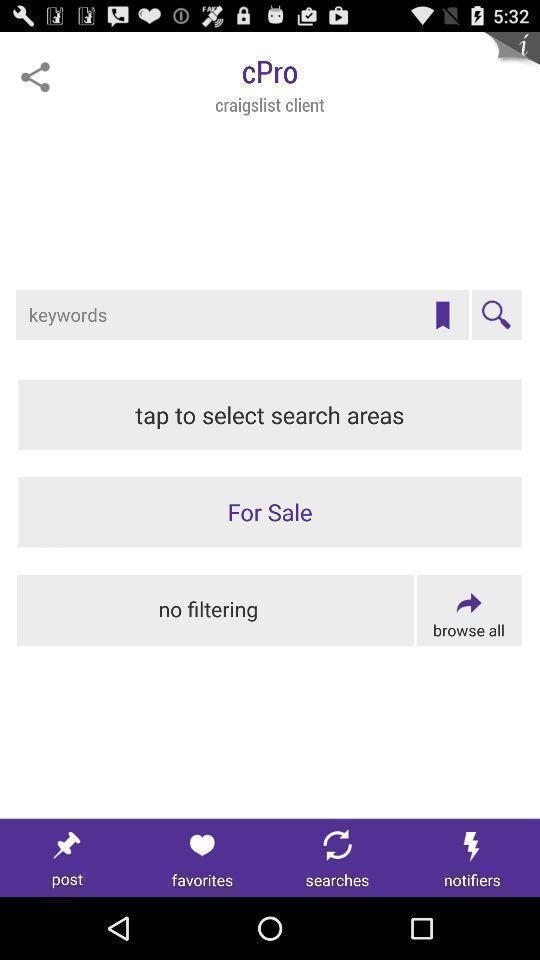Summarize the main components in this picture. Window displaying is a client page. 